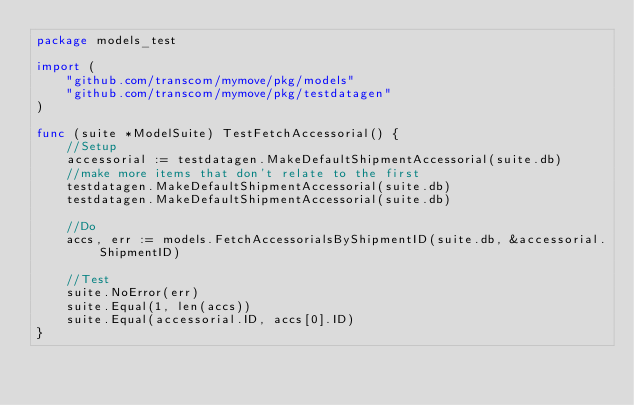Convert code to text. <code><loc_0><loc_0><loc_500><loc_500><_Go_>package models_test

import (
	"github.com/transcom/mymove/pkg/models"
	"github.com/transcom/mymove/pkg/testdatagen"
)

func (suite *ModelSuite) TestFetchAccessorial() {
	//Setup
	accessorial := testdatagen.MakeDefaultShipmentAccessorial(suite.db)
	//make more items that don't relate to the first
	testdatagen.MakeDefaultShipmentAccessorial(suite.db)
	testdatagen.MakeDefaultShipmentAccessorial(suite.db)

	//Do
	accs, err := models.FetchAccessorialsByShipmentID(suite.db, &accessorial.ShipmentID)

	//Test
	suite.NoError(err)
	suite.Equal(1, len(accs))
	suite.Equal(accessorial.ID, accs[0].ID)
}
</code> 